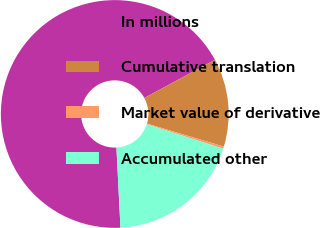<chart> <loc_0><loc_0><loc_500><loc_500><pie_chart><fcel>In millions<fcel>Cumulative translation<fcel>Market value of derivative<fcel>Accumulated other<nl><fcel>67.91%<fcel>12.51%<fcel>0.31%<fcel>19.27%<nl></chart> 